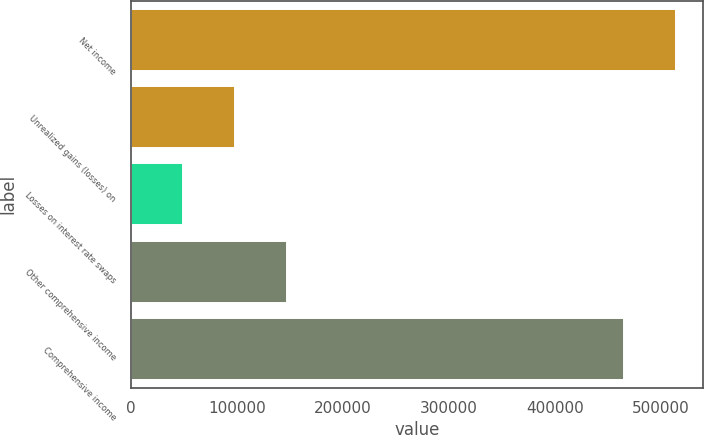Convert chart. <chart><loc_0><loc_0><loc_500><loc_500><bar_chart><fcel>Net income<fcel>Unrealized gains (losses) on<fcel>Losses on interest rate swaps<fcel>Other comprehensive income<fcel>Comprehensive income<nl><fcel>514490<fcel>98363.8<fcel>49292.4<fcel>147435<fcel>465419<nl></chart> 